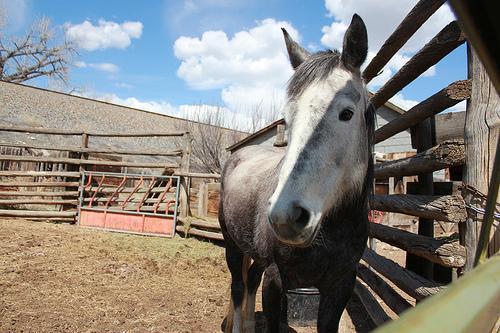How many ears does the horse have?
Give a very brief answer. 2. How many feet does the horse have?
Give a very brief answer. 4. 